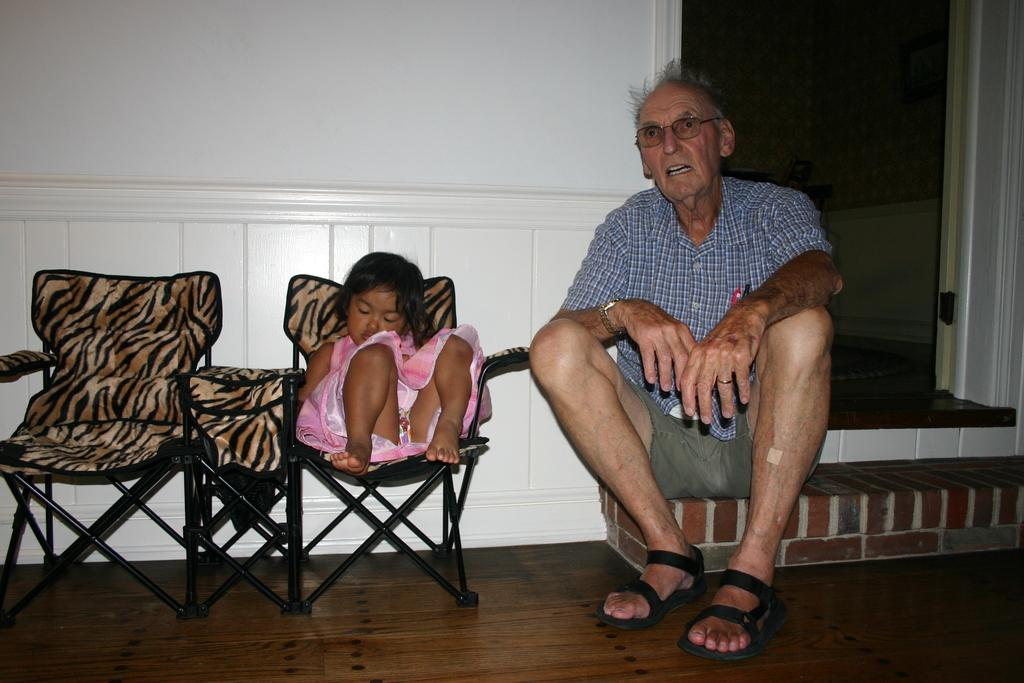What is the girl doing in the image? The girl is sitting on a chair in the image. Where is the man sitting in the image? The man is sitting on a stair in the image. What accessories is the man wearing? The man is wearing spectacles and a wristwatch in the image. What is on the floor in the image? There is a carpet on the floor in the image. What type of cherries can be seen on the girl's plate in the image? There are no cherries or plates present in the image; it only features a girl sitting on a chair and a man sitting on a stair. 